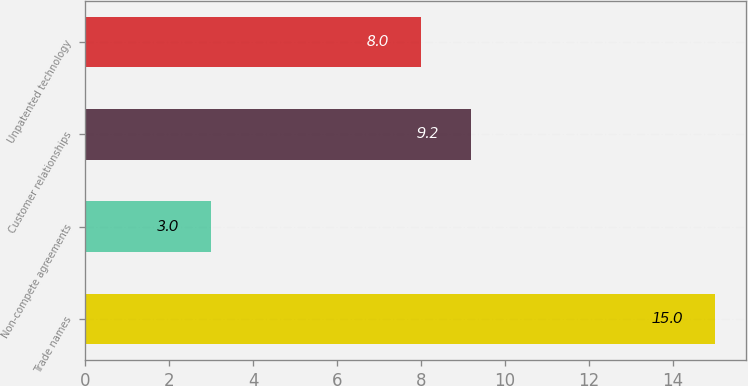Convert chart to OTSL. <chart><loc_0><loc_0><loc_500><loc_500><bar_chart><fcel>Trade names<fcel>Non-compete agreements<fcel>Customer relationships<fcel>Unpatented technology<nl><fcel>15<fcel>3<fcel>9.2<fcel>8<nl></chart> 